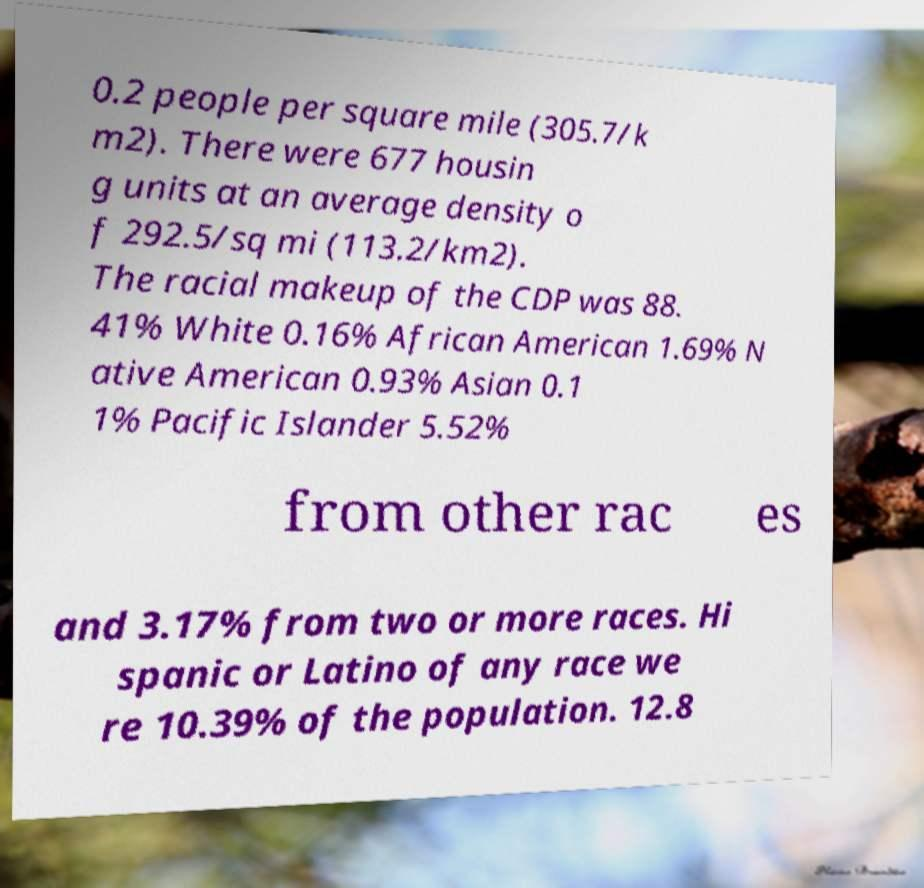Can you accurately transcribe the text from the provided image for me? 0.2 people per square mile (305.7/k m2). There were 677 housin g units at an average density o f 292.5/sq mi (113.2/km2). The racial makeup of the CDP was 88. 41% White 0.16% African American 1.69% N ative American 0.93% Asian 0.1 1% Pacific Islander 5.52% from other rac es and 3.17% from two or more races. Hi spanic or Latino of any race we re 10.39% of the population. 12.8 